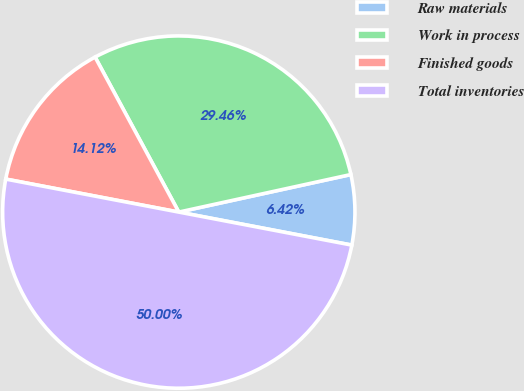Convert chart to OTSL. <chart><loc_0><loc_0><loc_500><loc_500><pie_chart><fcel>Raw materials<fcel>Work in process<fcel>Finished goods<fcel>Total inventories<nl><fcel>6.42%<fcel>29.46%<fcel>14.12%<fcel>50.0%<nl></chart> 